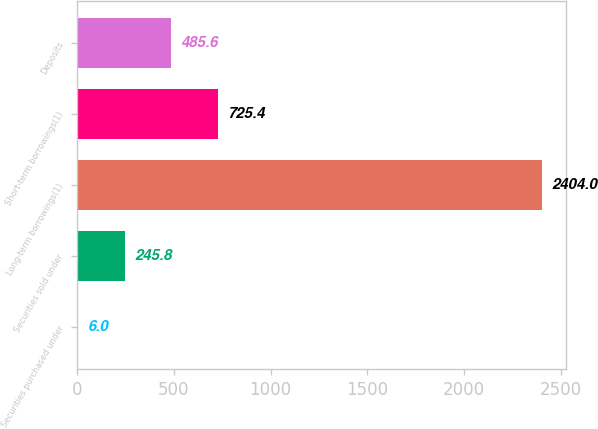Convert chart. <chart><loc_0><loc_0><loc_500><loc_500><bar_chart><fcel>Securities purchased under<fcel>Securities sold under<fcel>Long-term borrowings(1)<fcel>Short-term borrowings(1)<fcel>Deposits<nl><fcel>6<fcel>245.8<fcel>2404<fcel>725.4<fcel>485.6<nl></chart> 